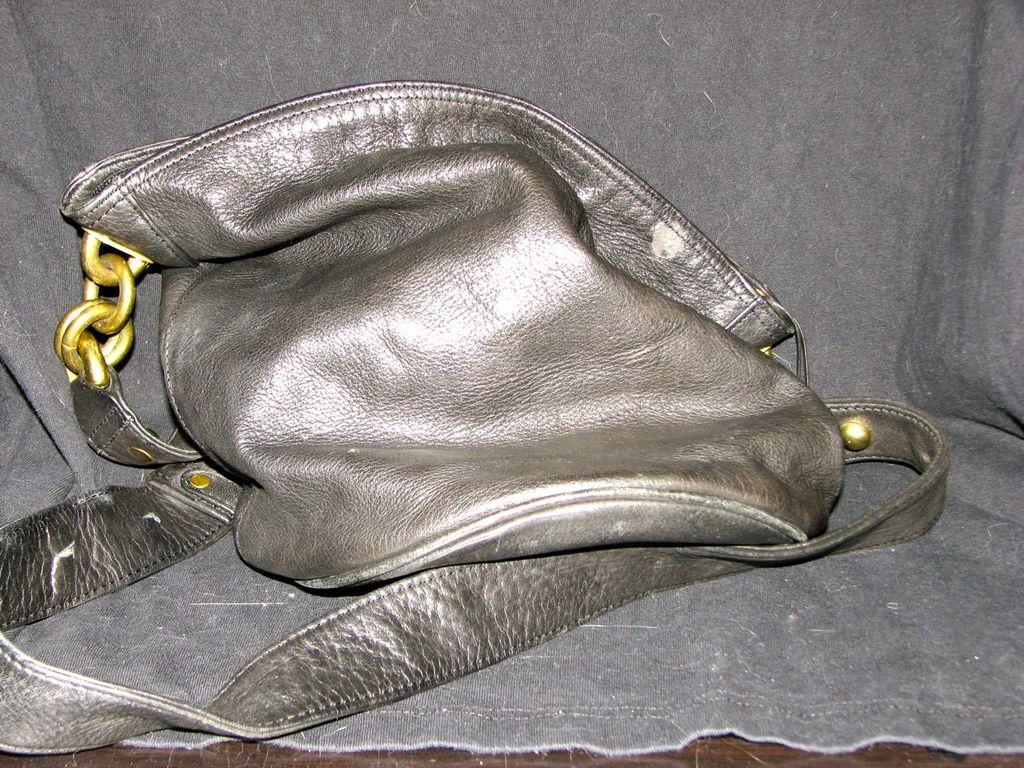What is the main subject of the image? The main subject of the image is a handbag. Can you describe the location of the handbag in the image? The handbag is in the middle of the image. How many horses are visible in the image? There are no horses present in the image; it features a handbag. What type of friction can be observed between the handbag and the surface it is placed on? There is no information about the friction between the handbag and the surface it is placed on in the image. 